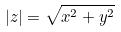<formula> <loc_0><loc_0><loc_500><loc_500>| z | = \sqrt { x ^ { 2 } + y ^ { 2 } }</formula> 